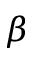<formula> <loc_0><loc_0><loc_500><loc_500>\beta</formula> 